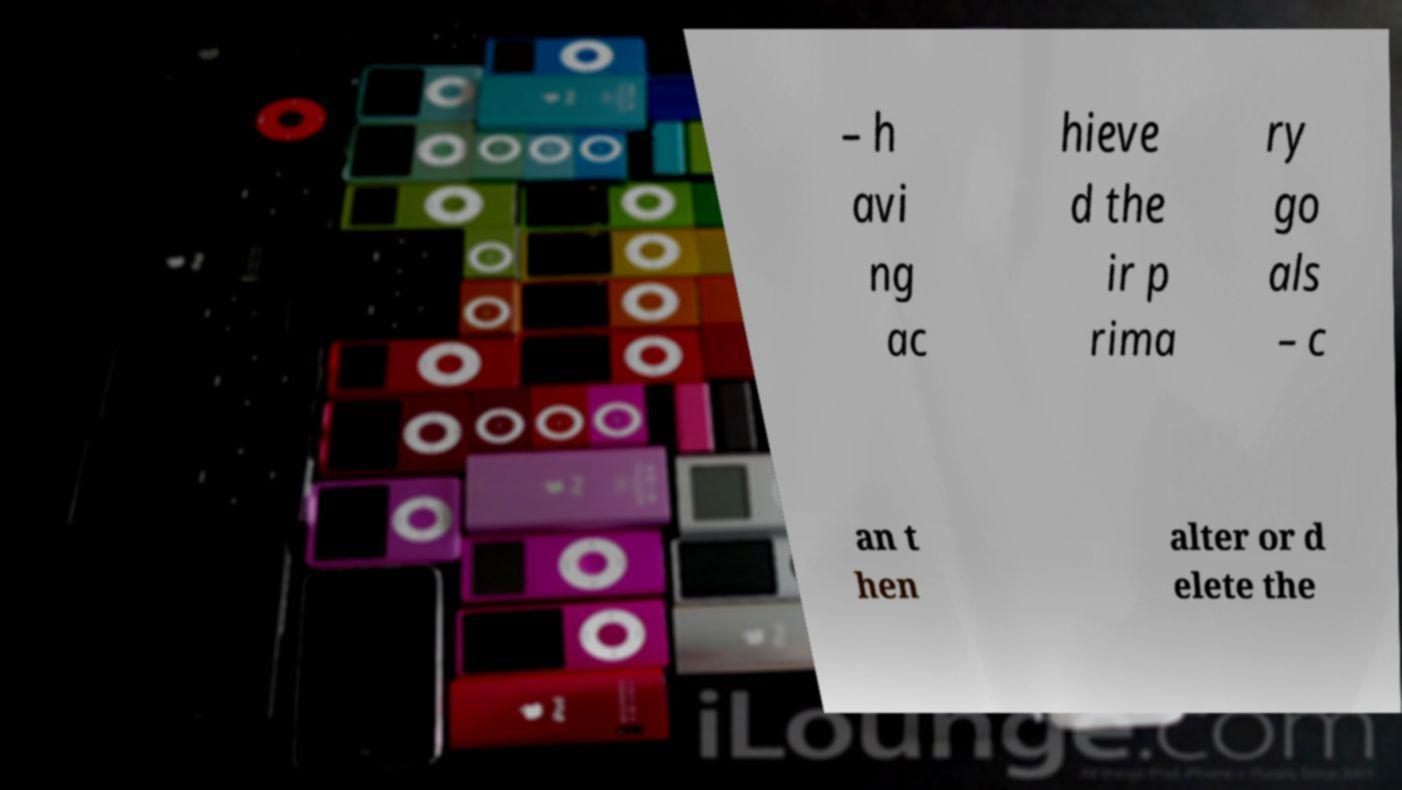I need the written content from this picture converted into text. Can you do that? – h avi ng ac hieve d the ir p rima ry go als – c an t hen alter or d elete the 